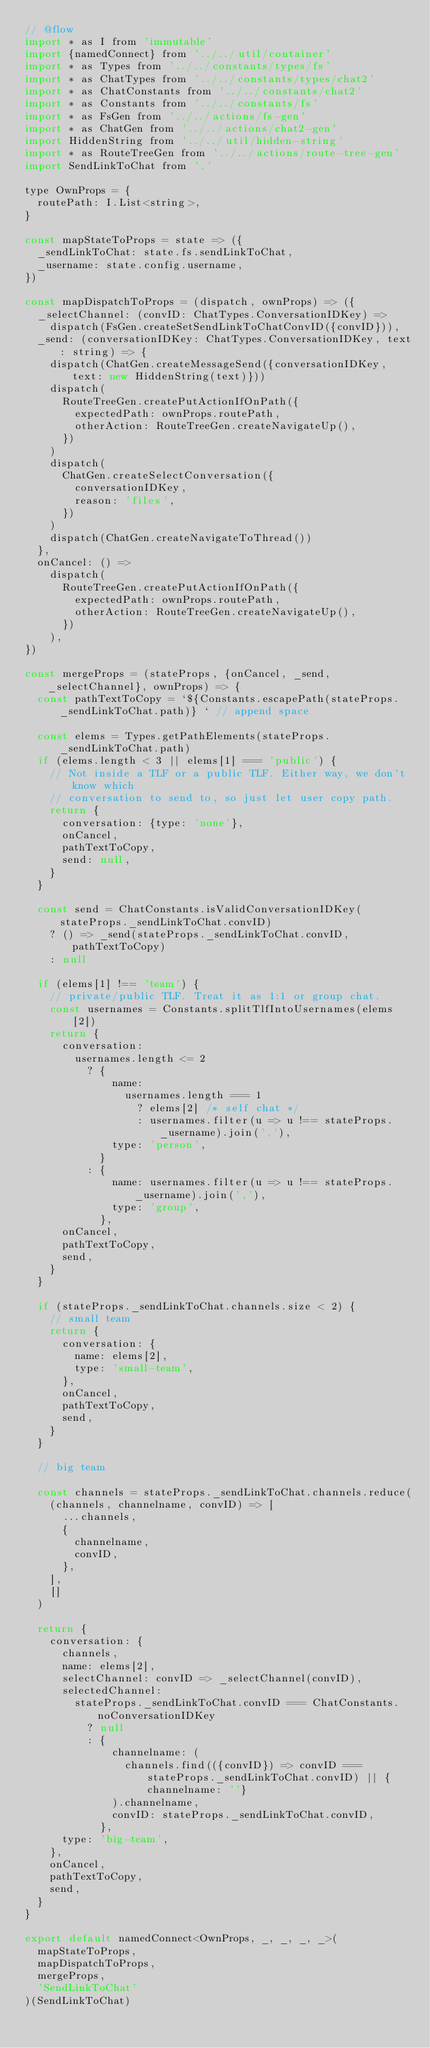Convert code to text. <code><loc_0><loc_0><loc_500><loc_500><_JavaScript_>// @flow
import * as I from 'immutable'
import {namedConnect} from '../../util/container'
import * as Types from '../../constants/types/fs'
import * as ChatTypes from '../../constants/types/chat2'
import * as ChatConstants from '../../constants/chat2'
import * as Constants from '../../constants/fs'
import * as FsGen from '../../actions/fs-gen'
import * as ChatGen from '../../actions/chat2-gen'
import HiddenString from '../../util/hidden-string'
import * as RouteTreeGen from '../../actions/route-tree-gen'
import SendLinkToChat from '.'

type OwnProps = {
  routePath: I.List<string>,
}

const mapStateToProps = state => ({
  _sendLinkToChat: state.fs.sendLinkToChat,
  _username: state.config.username,
})

const mapDispatchToProps = (dispatch, ownProps) => ({
  _selectChannel: (convID: ChatTypes.ConversationIDKey) =>
    dispatch(FsGen.createSetSendLinkToChatConvID({convID})),
  _send: (conversationIDKey: ChatTypes.ConversationIDKey, text: string) => {
    dispatch(ChatGen.createMessageSend({conversationIDKey, text: new HiddenString(text)}))
    dispatch(
      RouteTreeGen.createPutActionIfOnPath({
        expectedPath: ownProps.routePath,
        otherAction: RouteTreeGen.createNavigateUp(),
      })
    )
    dispatch(
      ChatGen.createSelectConversation({
        conversationIDKey,
        reason: 'files',
      })
    )
    dispatch(ChatGen.createNavigateToThread())
  },
  onCancel: () =>
    dispatch(
      RouteTreeGen.createPutActionIfOnPath({
        expectedPath: ownProps.routePath,
        otherAction: RouteTreeGen.createNavigateUp(),
      })
    ),
})

const mergeProps = (stateProps, {onCancel, _send, _selectChannel}, ownProps) => {
  const pathTextToCopy = `${Constants.escapePath(stateProps._sendLinkToChat.path)} ` // append space

  const elems = Types.getPathElements(stateProps._sendLinkToChat.path)
  if (elems.length < 3 || elems[1] === 'public') {
    // Not inside a TLF or a public TLF. Either way, we don't know which
    // conversation to send to, so just let user copy path.
    return {
      conversation: {type: 'none'},
      onCancel,
      pathTextToCopy,
      send: null,
    }
  }

  const send = ChatConstants.isValidConversationIDKey(stateProps._sendLinkToChat.convID)
    ? () => _send(stateProps._sendLinkToChat.convID, pathTextToCopy)
    : null

  if (elems[1] !== 'team') {
    // private/public TLF. Treat it as 1:1 or group chat.
    const usernames = Constants.splitTlfIntoUsernames(elems[2])
    return {
      conversation:
        usernames.length <= 2
          ? {
              name:
                usernames.length === 1
                  ? elems[2] /* self chat */
                  : usernames.filter(u => u !== stateProps._username).join(','),
              type: 'person',
            }
          : {
              name: usernames.filter(u => u !== stateProps._username).join(','),
              type: 'group',
            },
      onCancel,
      pathTextToCopy,
      send,
    }
  }

  if (stateProps._sendLinkToChat.channels.size < 2) {
    // small team
    return {
      conversation: {
        name: elems[2],
        type: 'small-team',
      },
      onCancel,
      pathTextToCopy,
      send,
    }
  }

  // big team

  const channels = stateProps._sendLinkToChat.channels.reduce(
    (channels, channelname, convID) => [
      ...channels,
      {
        channelname,
        convID,
      },
    ],
    []
  )

  return {
    conversation: {
      channels,
      name: elems[2],
      selectChannel: convID => _selectChannel(convID),
      selectedChannel:
        stateProps._sendLinkToChat.convID === ChatConstants.noConversationIDKey
          ? null
          : {
              channelname: (
                channels.find(({convID}) => convID === stateProps._sendLinkToChat.convID) || {channelname: ''}
              ).channelname,
              convID: stateProps._sendLinkToChat.convID,
            },
      type: 'big-team',
    },
    onCancel,
    pathTextToCopy,
    send,
  }
}

export default namedConnect<OwnProps, _, _, _, _>(
  mapStateToProps,
  mapDispatchToProps,
  mergeProps,
  'SendLinkToChat'
)(SendLinkToChat)
</code> 